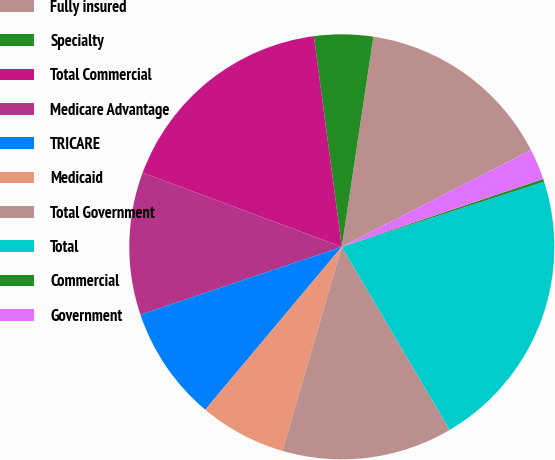<chart> <loc_0><loc_0><loc_500><loc_500><pie_chart><fcel>Fully insured<fcel>Specialty<fcel>Total Commercial<fcel>Medicare Advantage<fcel>TRICARE<fcel>Medicaid<fcel>Total Government<fcel>Total<fcel>Commercial<fcel>Government<nl><fcel>15.1%<fcel>4.47%<fcel>17.23%<fcel>10.85%<fcel>8.72%<fcel>6.6%<fcel>12.98%<fcel>21.48%<fcel>0.22%<fcel>2.35%<nl></chart> 